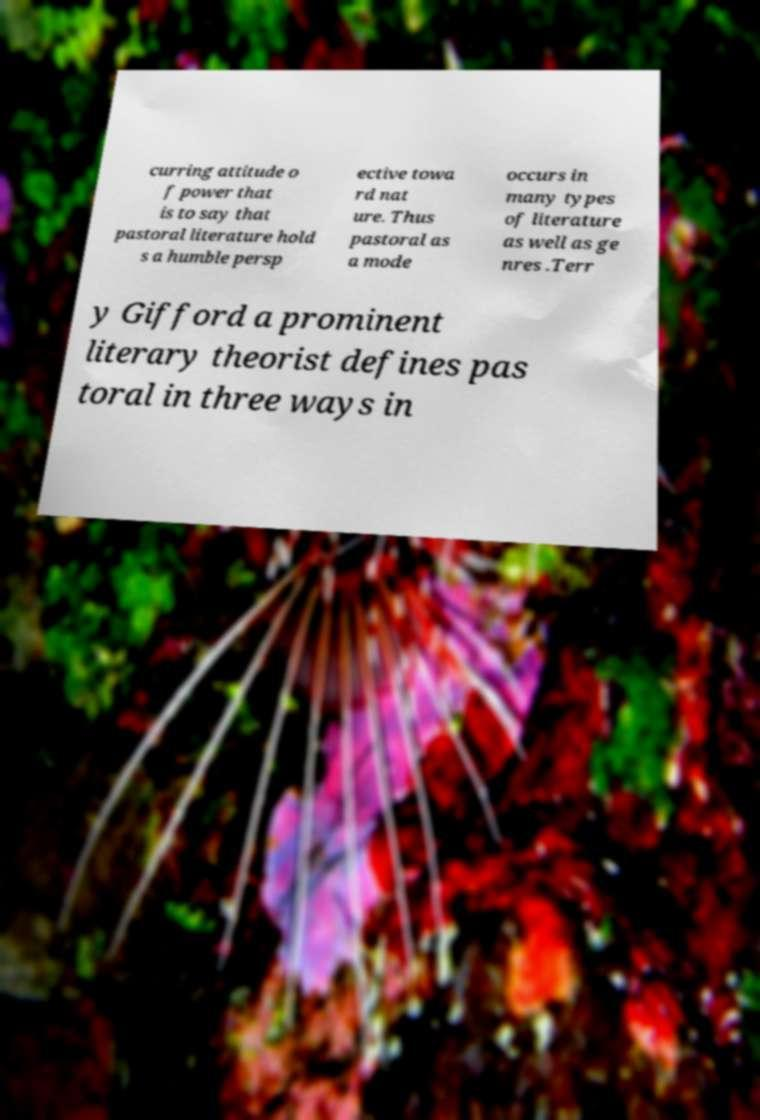Can you accurately transcribe the text from the provided image for me? curring attitude o f power that is to say that pastoral literature hold s a humble persp ective towa rd nat ure. Thus pastoral as a mode occurs in many types of literature as well as ge nres .Terr y Gifford a prominent literary theorist defines pas toral in three ways in 